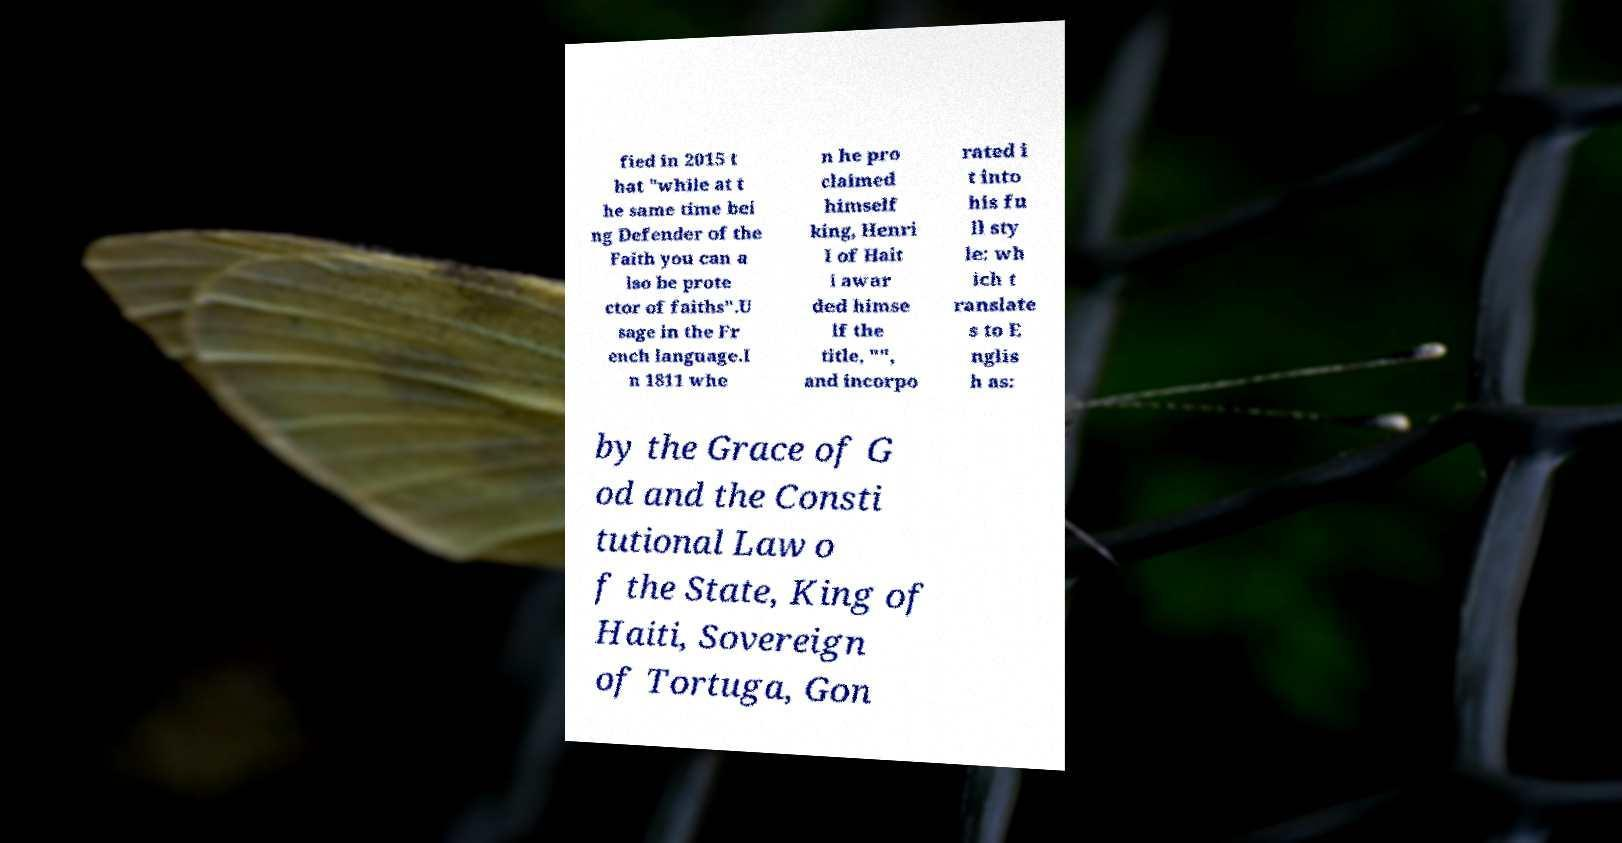There's text embedded in this image that I need extracted. Can you transcribe it verbatim? fied in 2015 t hat "while at t he same time bei ng Defender of the Faith you can a lso be prote ctor of faiths".U sage in the Fr ench language.I n 1811 whe n he pro claimed himself king, Henri I of Hait i awar ded himse lf the title, "", and incorpo rated i t into his fu ll sty le: wh ich t ranslate s to E nglis h as: by the Grace of G od and the Consti tutional Law o f the State, King of Haiti, Sovereign of Tortuga, Gon 